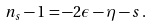Convert formula to latex. <formula><loc_0><loc_0><loc_500><loc_500>n _ { s } - 1 = - 2 \epsilon - \eta - s \, .</formula> 